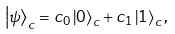<formula> <loc_0><loc_0><loc_500><loc_500>\left | \psi \right \rangle _ { c } = c _ { 0 } \left | 0 \right \rangle _ { c } + c _ { 1 } \left | 1 \right \rangle _ { c } ,</formula> 